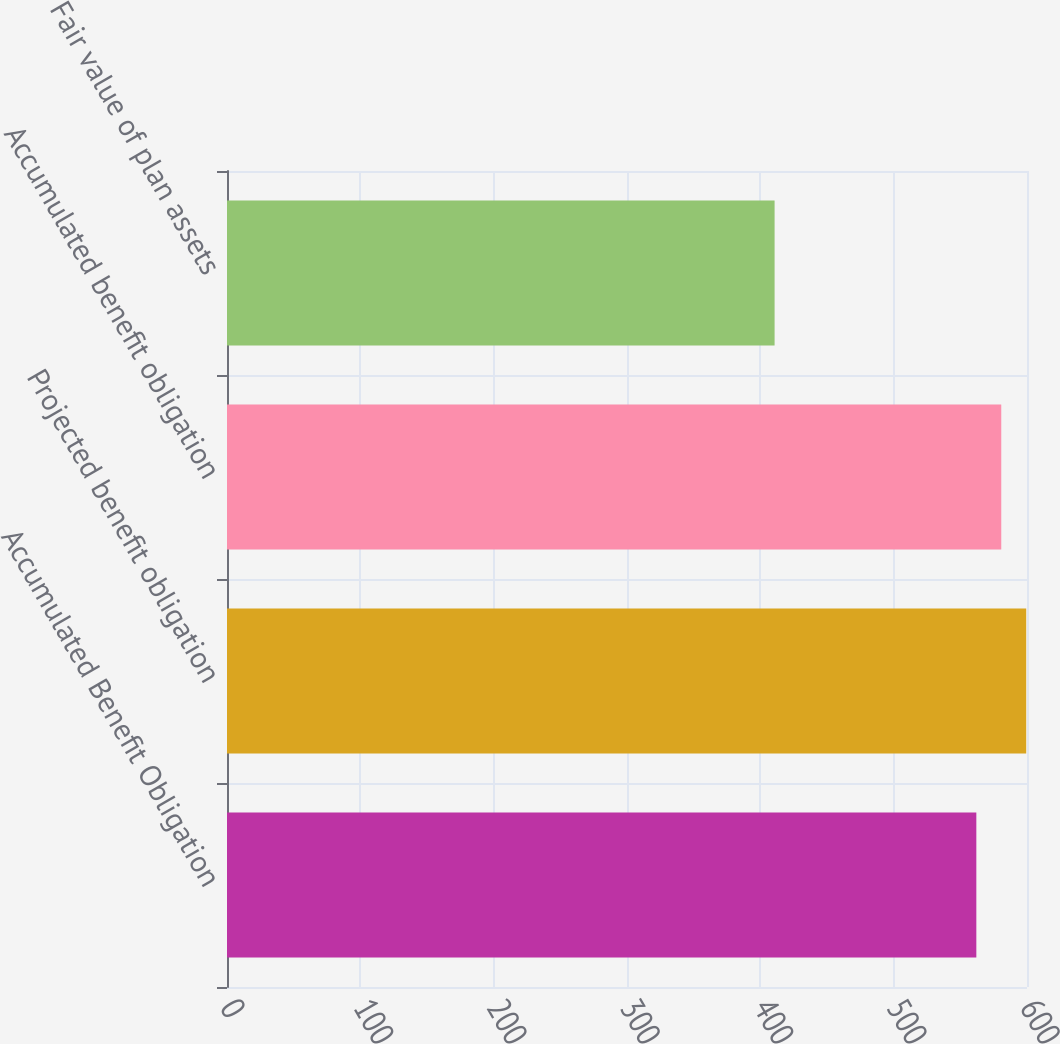Convert chart to OTSL. <chart><loc_0><loc_0><loc_500><loc_500><bar_chart><fcel>Accumulated Benefit Obligation<fcel>Projected benefit obligation<fcel>Accumulated benefit obligation<fcel>Fair value of plan assets<nl><fcel>562<fcel>599.4<fcel>580.7<fcel>410.7<nl></chart> 